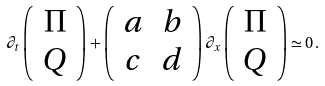<formula> <loc_0><loc_0><loc_500><loc_500>\partial _ { t } \left ( \begin{array} { c c } \Pi \\ Q \end{array} \right ) + \left ( \begin{array} { c c } a & b \\ c & d \end{array} \right ) \partial _ { x } \left ( \begin{array} { c } \Pi \\ Q \end{array} \right ) \simeq 0 \, .</formula> 